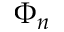<formula> <loc_0><loc_0><loc_500><loc_500>\Phi _ { n }</formula> 